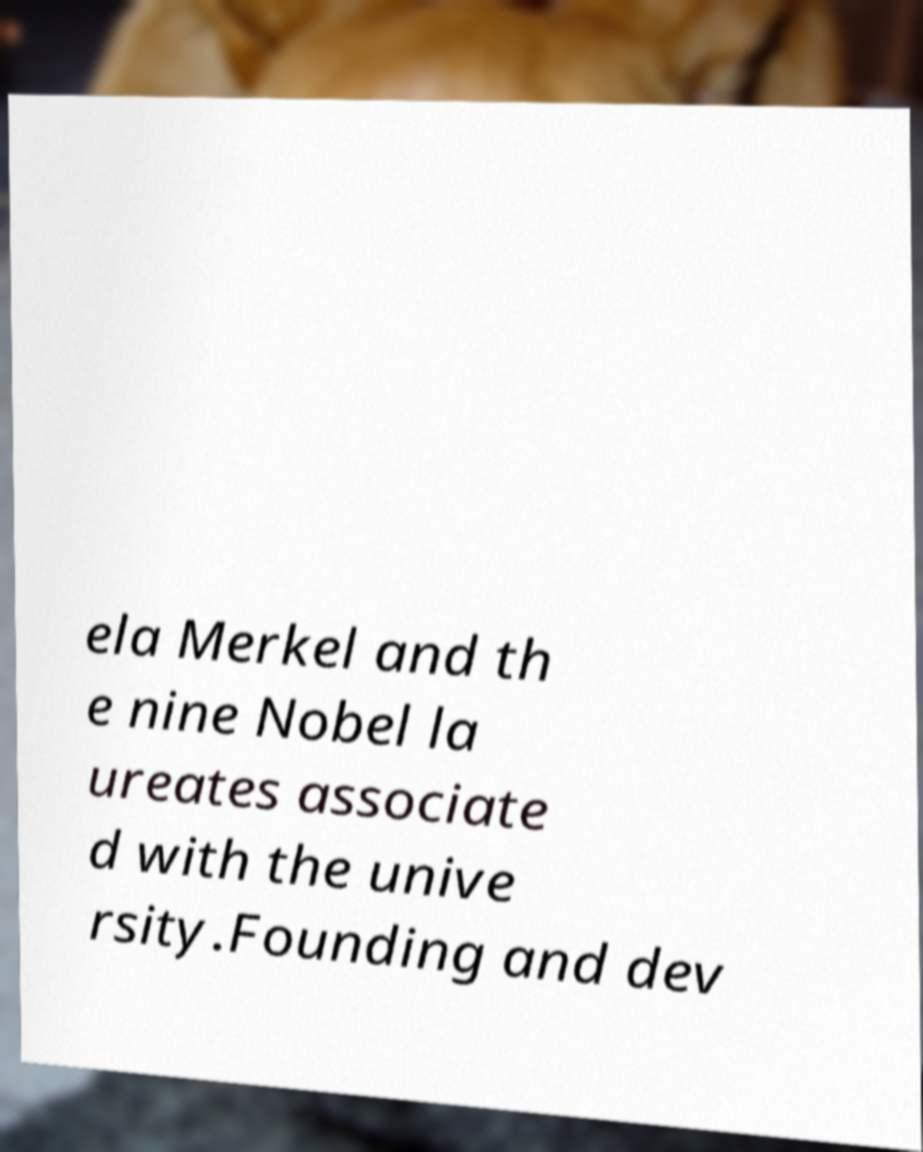Please identify and transcribe the text found in this image. ela Merkel and th e nine Nobel la ureates associate d with the unive rsity.Founding and dev 